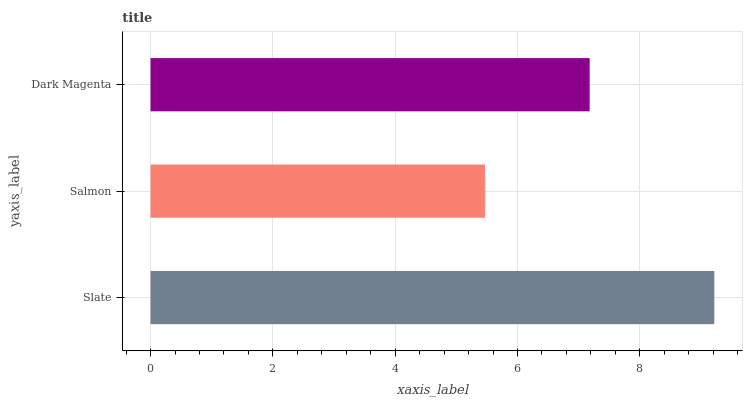Is Salmon the minimum?
Answer yes or no. Yes. Is Slate the maximum?
Answer yes or no. Yes. Is Dark Magenta the minimum?
Answer yes or no. No. Is Dark Magenta the maximum?
Answer yes or no. No. Is Dark Magenta greater than Salmon?
Answer yes or no. Yes. Is Salmon less than Dark Magenta?
Answer yes or no. Yes. Is Salmon greater than Dark Magenta?
Answer yes or no. No. Is Dark Magenta less than Salmon?
Answer yes or no. No. Is Dark Magenta the high median?
Answer yes or no. Yes. Is Dark Magenta the low median?
Answer yes or no. Yes. Is Slate the high median?
Answer yes or no. No. Is Salmon the low median?
Answer yes or no. No. 